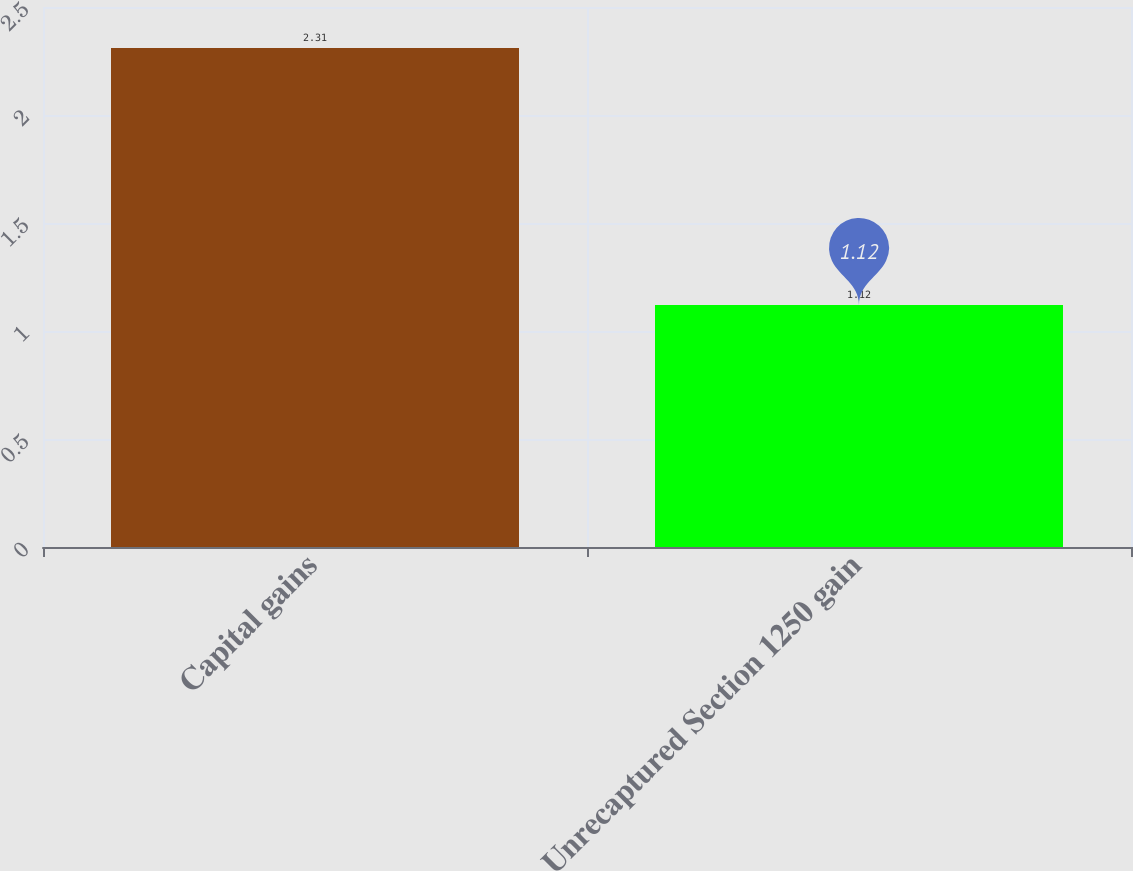Convert chart to OTSL. <chart><loc_0><loc_0><loc_500><loc_500><bar_chart><fcel>Capital gains<fcel>Unrecaptured Section 1250 gain<nl><fcel>2.31<fcel>1.12<nl></chart> 